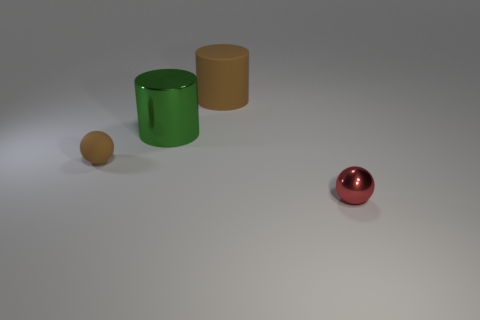Add 1 yellow rubber cylinders. How many objects exist? 5 Subtract 0 purple cylinders. How many objects are left? 4 Subtract all large matte objects. Subtract all tiny cyan matte cubes. How many objects are left? 3 Add 2 large shiny cylinders. How many large shiny cylinders are left? 3 Add 4 large cyan cylinders. How many large cyan cylinders exist? 4 